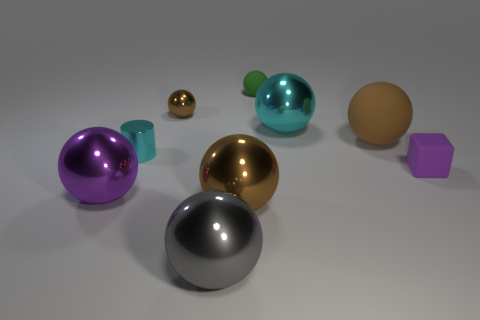Subtract all brown balls. How many were subtracted if there are1brown balls left? 2 Subtract all big brown metal spheres. How many spheres are left? 6 Subtract 7 spheres. How many spheres are left? 0 Subtract all green balls. How many balls are left? 6 Subtract all red cubes. How many brown spheres are left? 3 Subtract all cylinders. How many objects are left? 8 Subtract all brown cubes. Subtract all red spheres. How many cubes are left? 1 Subtract all tiny red matte blocks. Subtract all brown balls. How many objects are left? 6 Add 7 small purple matte cubes. How many small purple matte cubes are left? 8 Add 7 large cyan blocks. How many large cyan blocks exist? 7 